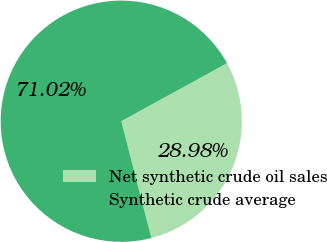Convert chart. <chart><loc_0><loc_0><loc_500><loc_500><pie_chart><fcel>Net synthetic crude oil sales<fcel>Synthetic crude average<nl><fcel>28.98%<fcel>71.02%<nl></chart> 